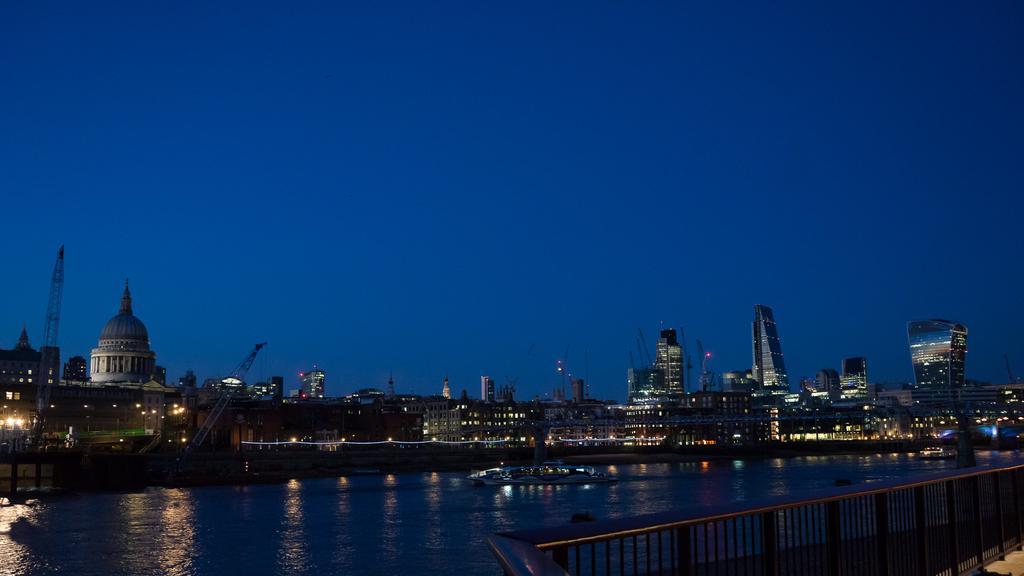Can you describe this image briefly? In the picture we can see a railing and beside it, we can see a lake with water and boat in it and behind it, we can see some house buildings with lights, palace, and a crane near the water and in the background we can see a sky. 